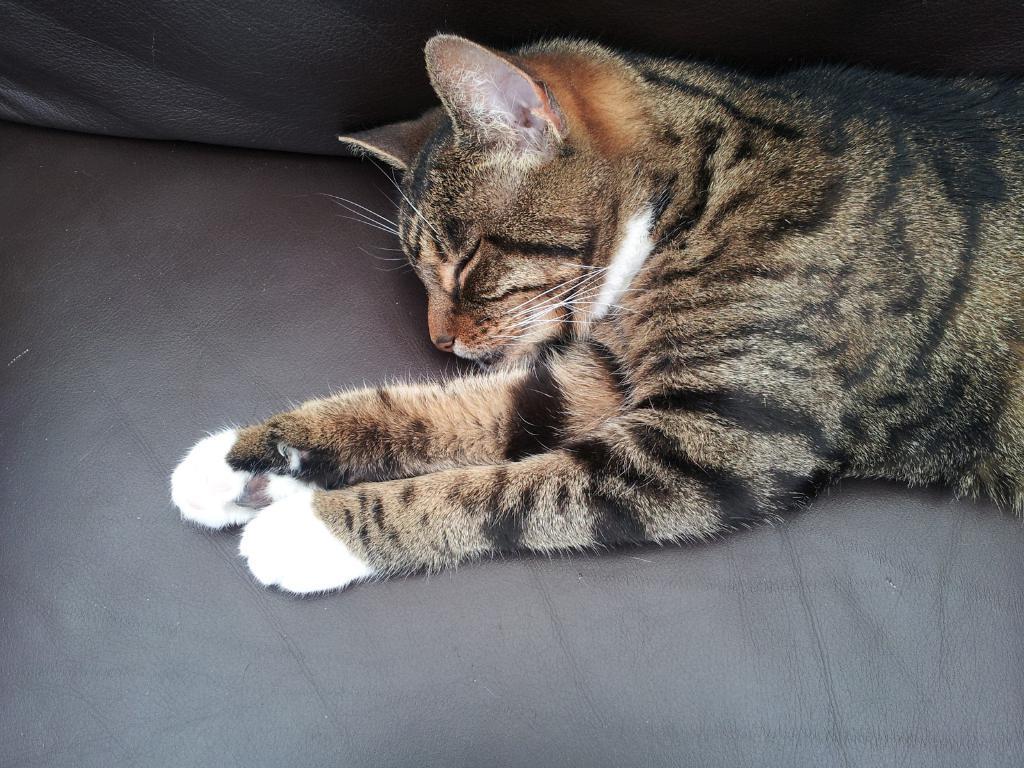Could you give a brief overview of what you see in this image? In this picture I can see there is a cat lying on the couch and it is sleeping. 